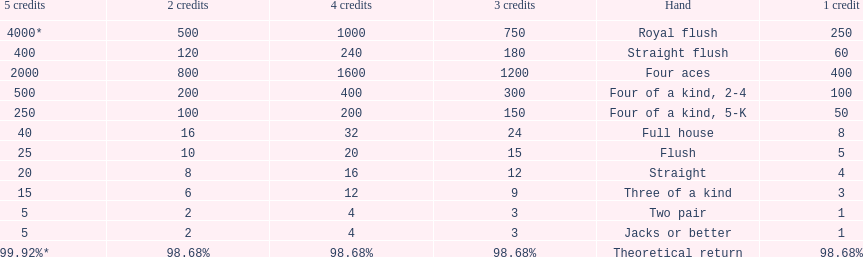What is the total amount of a 3 credit straight flush? 180. 